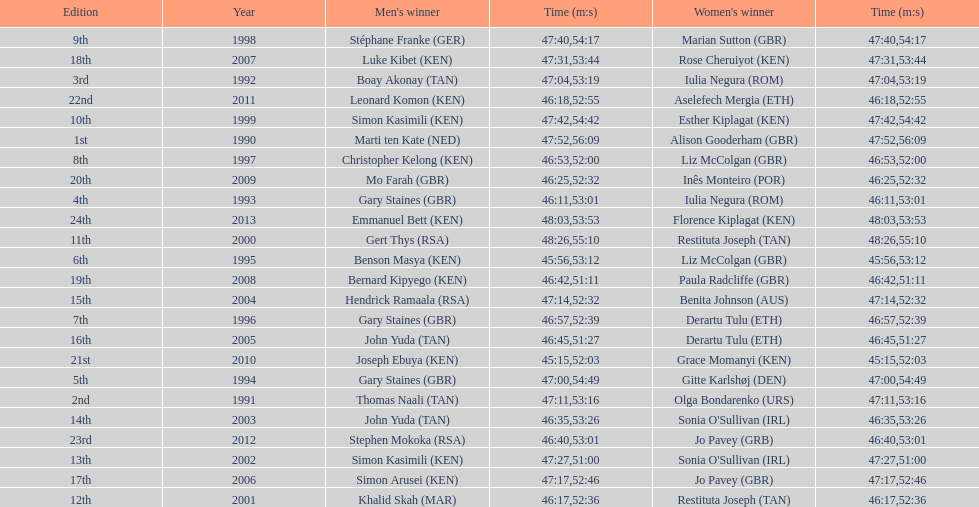Who is the male winner listed before gert thys? Simon Kasimili. 